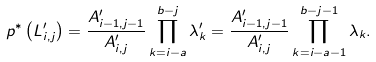Convert formula to latex. <formula><loc_0><loc_0><loc_500><loc_500>p ^ { * } \left ( L ^ { \prime } _ { i , j } \right ) = \frac { A ^ { \prime } _ { i - 1 , j - 1 } } { A ^ { \prime } _ { i , j } } \prod _ { k = i - a } ^ { b - j } \lambda ^ { \prime } _ { k } = \frac { A ^ { \prime } _ { i - 1 , j - 1 } } { A ^ { \prime } _ { i , j } } \prod _ { k = i - a - 1 } ^ { b - j - 1 } \lambda _ { k } .</formula> 